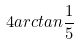<formula> <loc_0><loc_0><loc_500><loc_500>4 a r c t a n \frac { 1 } { 5 }</formula> 